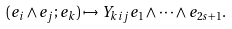Convert formula to latex. <formula><loc_0><loc_0><loc_500><loc_500>( e _ { i } \wedge e _ { j } ; e _ { k } ) \mapsto Y _ { k i j } e _ { 1 } \wedge \cdots \wedge e _ { 2 s + 1 } .</formula> 